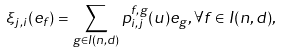Convert formula to latex. <formula><loc_0><loc_0><loc_500><loc_500>\xi _ { j , i } ( e _ { f } ) = \sum _ { g \in I ( n , d ) } p _ { i , j } ^ { f , g } ( u ) e _ { g } , \forall f \in I ( n , d ) ,</formula> 